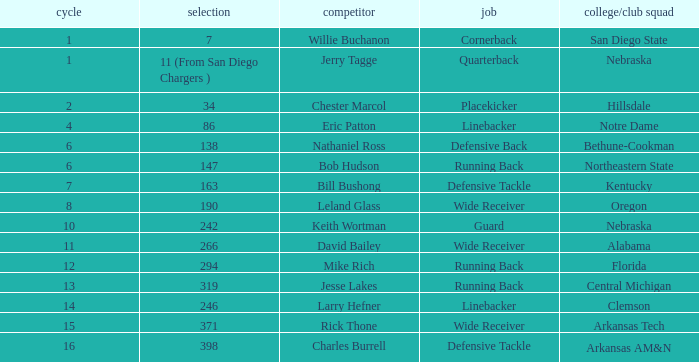Which choice has a school/club team that is kentucky? 163.0. 